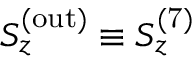Convert formula to latex. <formula><loc_0><loc_0><loc_500><loc_500>S _ { z } ^ { ( o u t ) } \equiv S _ { z } ^ { ( 7 ) }</formula> 